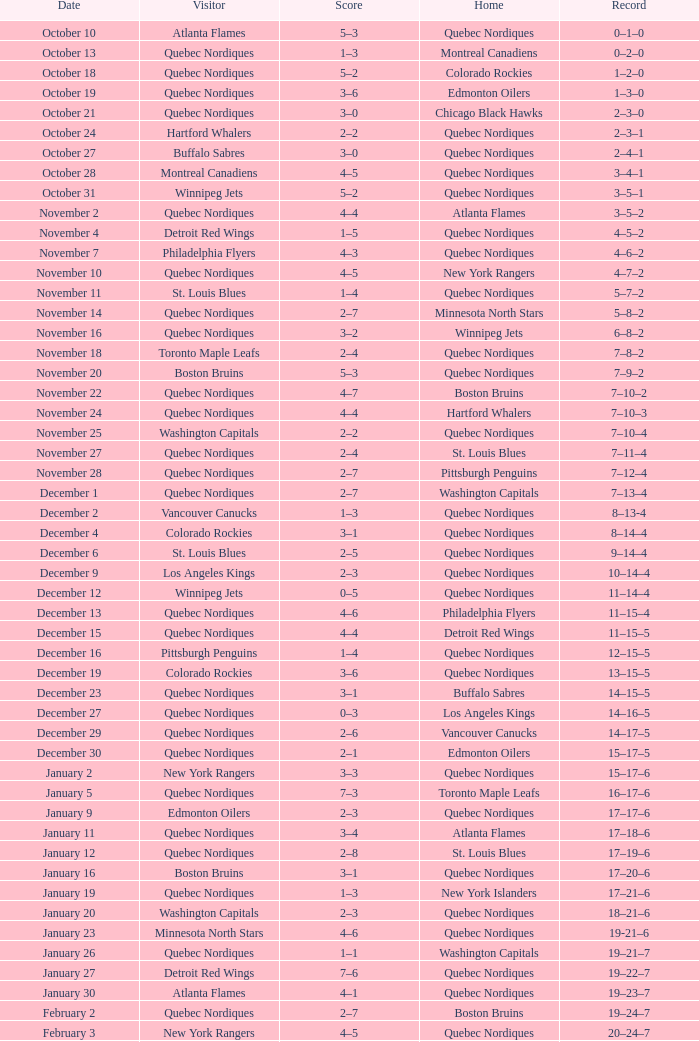What date is associated with a 2-7 score and a 5-8-2 record? November 14. 